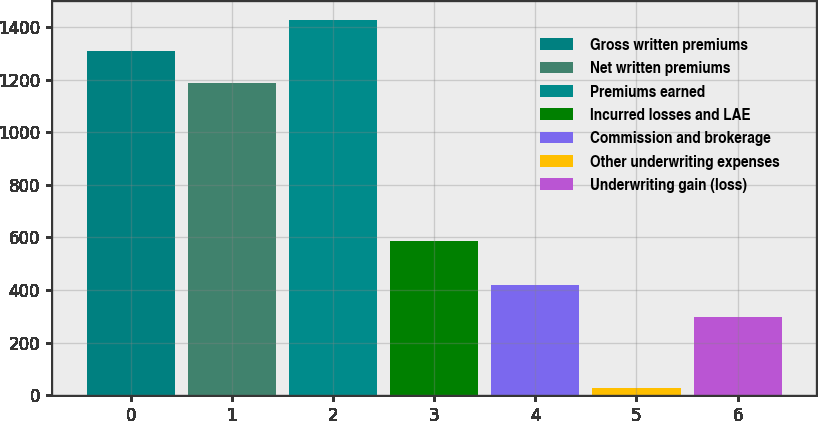Convert chart to OTSL. <chart><loc_0><loc_0><loc_500><loc_500><bar_chart><fcel>Gross written premiums<fcel>Net written premiums<fcel>Premiums earned<fcel>Incurred losses and LAE<fcel>Commission and brokerage<fcel>Other underwriting expenses<fcel>Underwriting gain (loss)<nl><fcel>1307.25<fcel>1188.7<fcel>1425.8<fcel>586.3<fcel>417.65<fcel>29.3<fcel>299.1<nl></chart> 